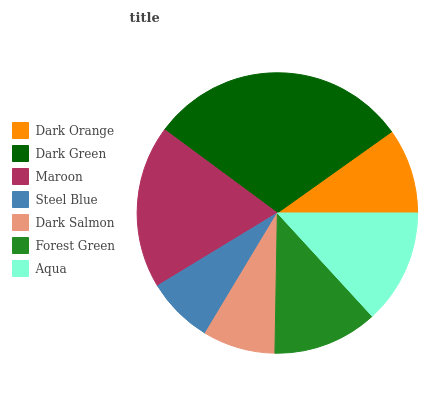Is Steel Blue the minimum?
Answer yes or no. Yes. Is Dark Green the maximum?
Answer yes or no. Yes. Is Maroon the minimum?
Answer yes or no. No. Is Maroon the maximum?
Answer yes or no. No. Is Dark Green greater than Maroon?
Answer yes or no. Yes. Is Maroon less than Dark Green?
Answer yes or no. Yes. Is Maroon greater than Dark Green?
Answer yes or no. No. Is Dark Green less than Maroon?
Answer yes or no. No. Is Forest Green the high median?
Answer yes or no. Yes. Is Forest Green the low median?
Answer yes or no. Yes. Is Dark Orange the high median?
Answer yes or no. No. Is Aqua the low median?
Answer yes or no. No. 